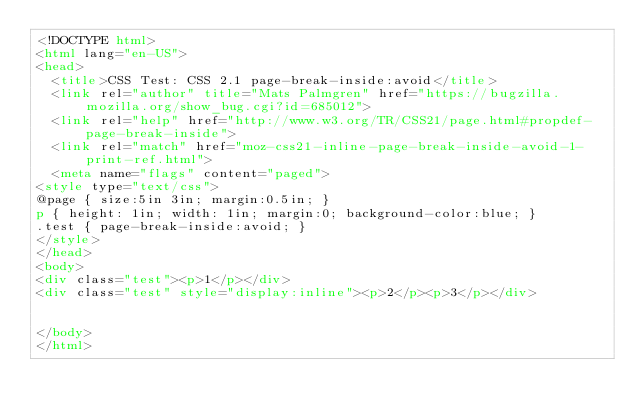<code> <loc_0><loc_0><loc_500><loc_500><_HTML_><!DOCTYPE html>
<html lang="en-US">
<head>
  <title>CSS Test: CSS 2.1 page-break-inside:avoid</title>
  <link rel="author" title="Mats Palmgren" href="https://bugzilla.mozilla.org/show_bug.cgi?id=685012">
  <link rel="help" href="http://www.w3.org/TR/CSS21/page.html#propdef-page-break-inside">
  <link rel="match" href="moz-css21-inline-page-break-inside-avoid-1-print-ref.html">
  <meta name="flags" content="paged">
<style type="text/css">
@page { size:5in 3in; margin:0.5in; }
p { height: 1in; width: 1in; margin:0; background-color:blue; }
.test { page-break-inside:avoid; }
</style>
</head>
<body>
<div class="test"><p>1</p></div>
<div class="test" style="display:inline"><p>2</p><p>3</p></div>


</body>
</html>
</code> 